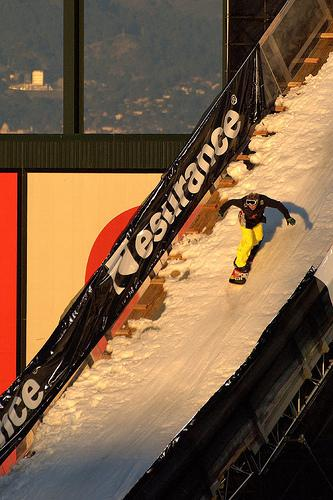Question: where is this picture taken?
Choices:
A. When snow can exist.
B. In winter.
C. In fall.
D. In spring.
Answer with the letter. Answer: A Question: who is this picture of?
Choices:
A. A skier.
B. A snowboarder.
C. A sledder.
D. A driver.
Answer with the letter. Answer: B Question: what is this picture showing?
Choices:
A. A man on a blue snowboard.
B. A man on a green snowboard.
C. A man on a white snowboard.
D. A man on a red snowboard.
Answer with the letter. Answer: D Question: what is the snowboarder doing?
Choices:
A. Going down a slope quickly.
B. Jumping.
C. Stopping.
D. Slowing down.
Answer with the letter. Answer: A 